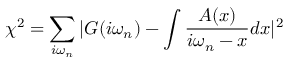Convert formula to latex. <formula><loc_0><loc_0><loc_500><loc_500>\chi ^ { 2 } = \sum _ { i \omega _ { n } } | G ( i \omega _ { n } ) - \int \frac { A ( x ) } { i \omega _ { n } - x } d x | ^ { 2 }</formula> 